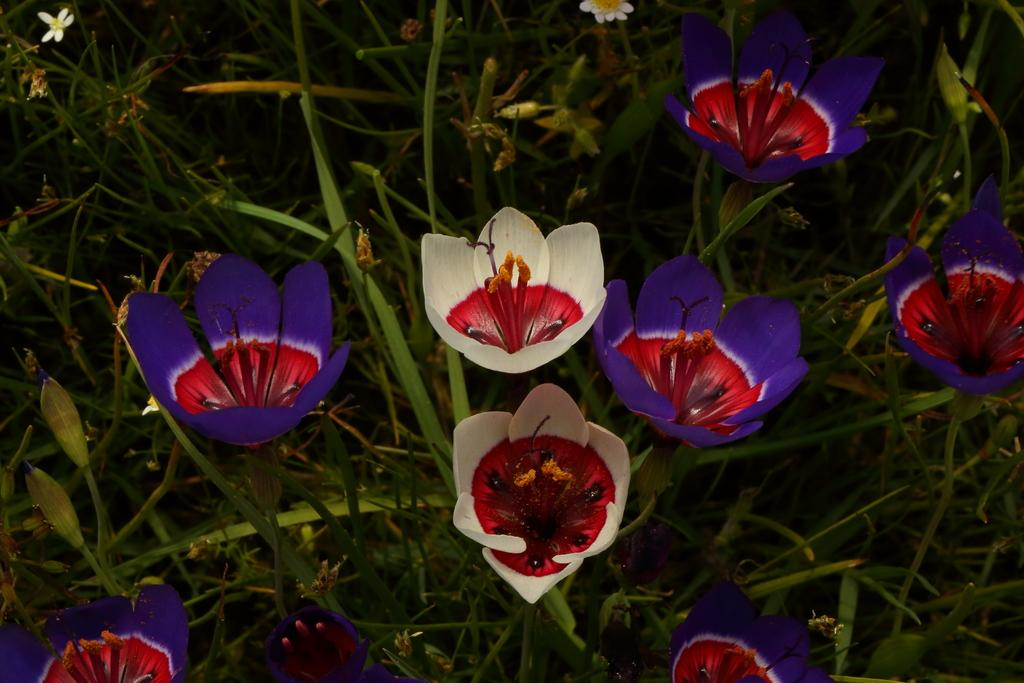What type of living organisms can be seen in the image? There are flowers and plants in the image. Can you describe the plants in the image? The plants in the image are not specified, but they are present alongside the flowers. Can you tell me how many people are swimming in the image? There is no swimming or people present in the image; it features flowers and plants. What is the mind of the flower in the image thinking? The mind of the flower is not applicable, as flowers do not have minds or thoughts. 